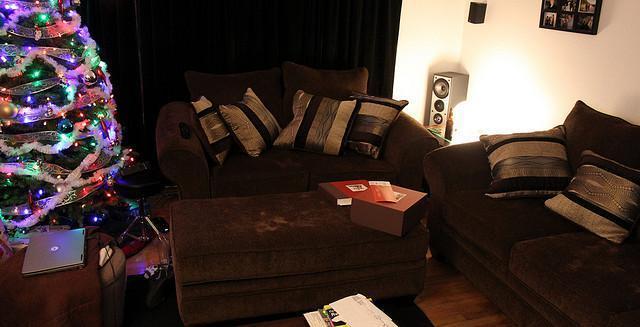How many pillows are on the furniture, excluding the ones that are part of the furniture?
Give a very brief answer. 6. How many couches are in the picture?
Give a very brief answer. 2. 